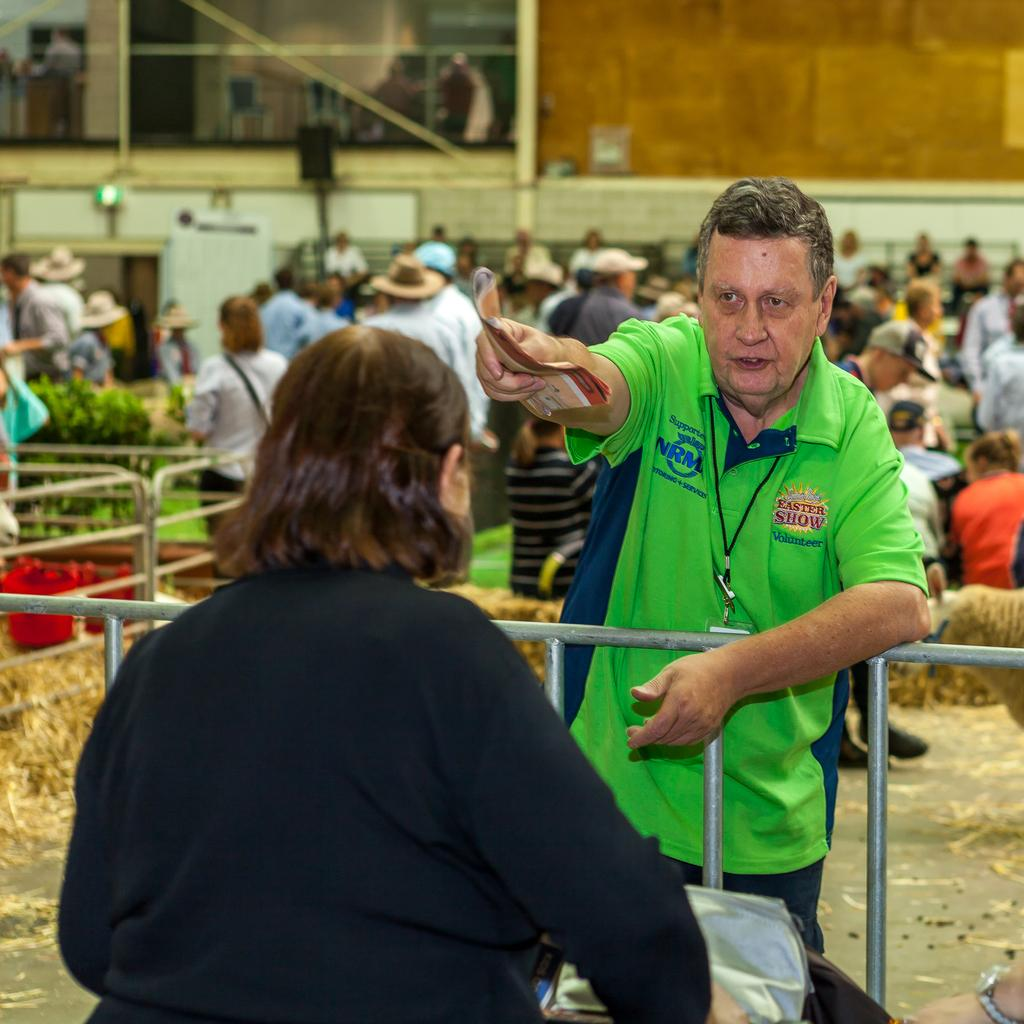What are the two people in the image doing? The two people in the image are standing and speaking to each other. What separates the two people in the image? There is a railing between the two people. What can be seen in the background of the image? There is a large crowd of people and a wall visible in the background of the image. What type of thunder can be heard in the image? There is no thunder present in the image; it is a visual representation and does not include sound. 